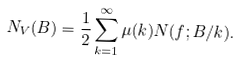Convert formula to latex. <formula><loc_0><loc_0><loc_500><loc_500>N _ { V } ( B ) = \frac { 1 } { 2 } \sum _ { k = 1 } ^ { \infty } \mu ( k ) N ( f ; B / k ) .</formula> 